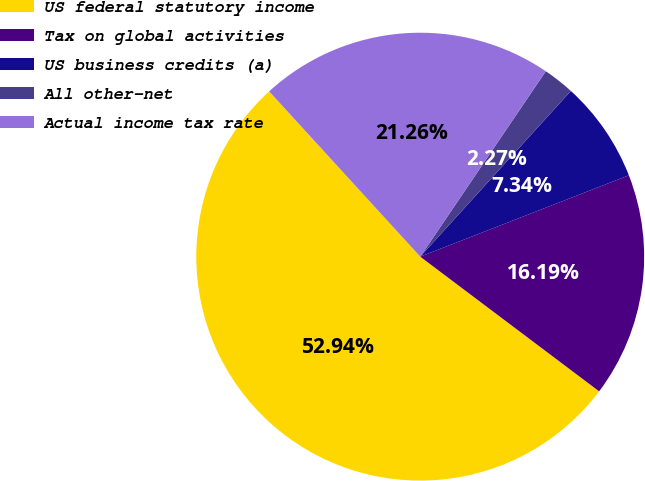Convert chart. <chart><loc_0><loc_0><loc_500><loc_500><pie_chart><fcel>US federal statutory income<fcel>Tax on global activities<fcel>US business credits (a)<fcel>All other-net<fcel>Actual income tax rate<nl><fcel>52.95%<fcel>16.19%<fcel>7.34%<fcel>2.27%<fcel>21.26%<nl></chart> 